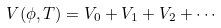<formula> <loc_0><loc_0><loc_500><loc_500>V ( \phi , T ) = V _ { 0 } + V _ { 1 } + V _ { 2 } + \cdots</formula> 